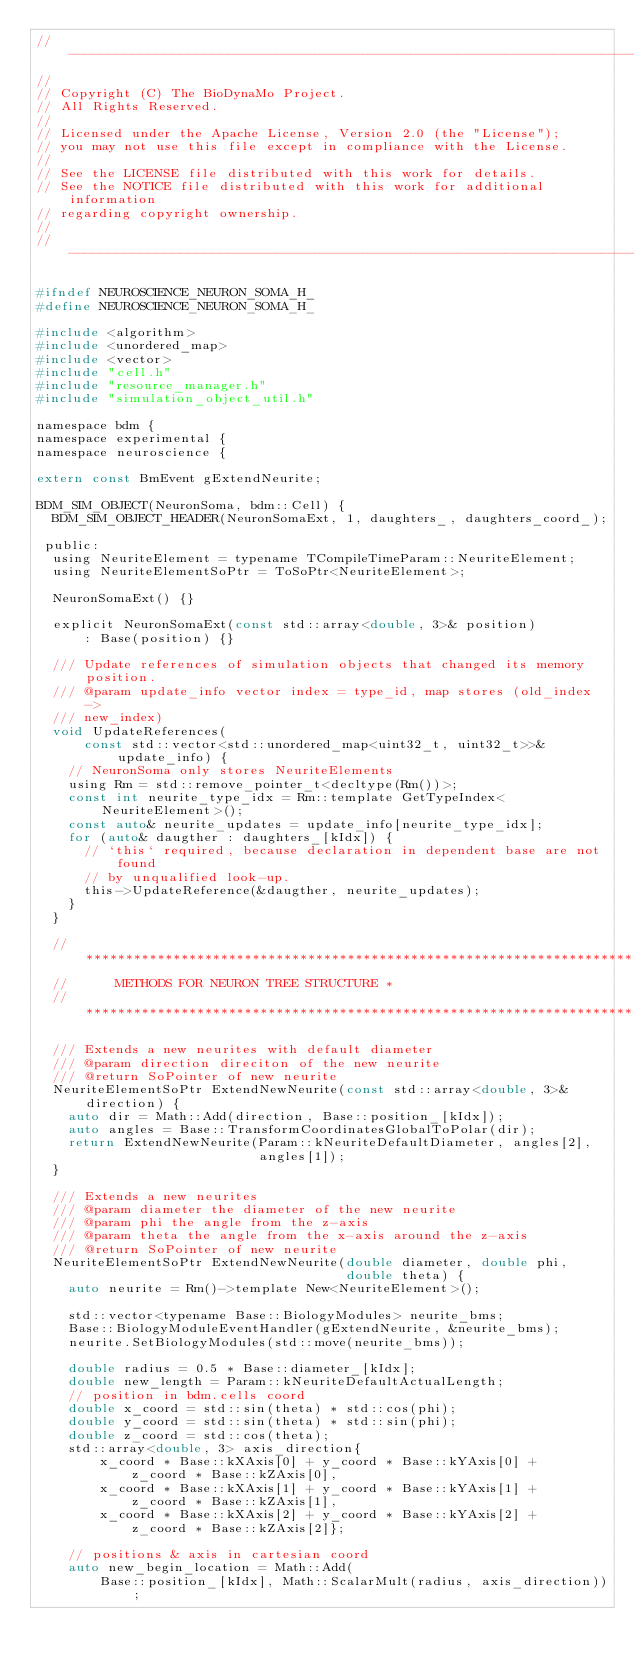<code> <loc_0><loc_0><loc_500><loc_500><_C_>// -----------------------------------------------------------------------------
//
// Copyright (C) The BioDynaMo Project.
// All Rights Reserved.
//
// Licensed under the Apache License, Version 2.0 (the "License");
// you may not use this file except in compliance with the License.
//
// See the LICENSE file distributed with this work for details.
// See the NOTICE file distributed with this work for additional information
// regarding copyright ownership.
//
// -----------------------------------------------------------------------------

#ifndef NEUROSCIENCE_NEURON_SOMA_H_
#define NEUROSCIENCE_NEURON_SOMA_H_

#include <algorithm>
#include <unordered_map>
#include <vector>
#include "cell.h"
#include "resource_manager.h"
#include "simulation_object_util.h"

namespace bdm {
namespace experimental {
namespace neuroscience {

extern const BmEvent gExtendNeurite;

BDM_SIM_OBJECT(NeuronSoma, bdm::Cell) {
  BDM_SIM_OBJECT_HEADER(NeuronSomaExt, 1, daughters_, daughters_coord_);

 public:
  using NeuriteElement = typename TCompileTimeParam::NeuriteElement;
  using NeuriteElementSoPtr = ToSoPtr<NeuriteElement>;

  NeuronSomaExt() {}

  explicit NeuronSomaExt(const std::array<double, 3>& position)
      : Base(position) {}

  /// Update references of simulation objects that changed its memory position.
  /// @param update_info vector index = type_id, map stores (old_index ->
  /// new_index)
  void UpdateReferences(
      const std::vector<std::unordered_map<uint32_t, uint32_t>>& update_info) {
    // NeuronSoma only stores NeuriteElements
    using Rm = std::remove_pointer_t<decltype(Rm())>;
    const int neurite_type_idx = Rm::template GetTypeIndex<NeuriteElement>();
    const auto& neurite_updates = update_info[neurite_type_idx];
    for (auto& daugther : daughters_[kIdx]) {
      // `this` required, because declaration in dependent base are not found
      // by unqualified look-up.
      this->UpdateReference(&daugther, neurite_updates);
    }
  }

  // ***************************************************************************
  //      METHODS FOR NEURON TREE STRUCTURE *
  // ***************************************************************************

  /// Extends a new neurites with default diameter
  /// @param direction direciton of the new neurite
  /// @return SoPointer of new neurite
  NeuriteElementSoPtr ExtendNewNeurite(const std::array<double, 3>& direction) {
    auto dir = Math::Add(direction, Base::position_[kIdx]);
    auto angles = Base::TransformCoordinatesGlobalToPolar(dir);
    return ExtendNewNeurite(Param::kNeuriteDefaultDiameter, angles[2],
                            angles[1]);
  }

  /// Extends a new neurites
  /// @param diameter the diameter of the new neurite
  /// @param phi the angle from the z-axis
  /// @param theta the angle from the x-axis around the z-axis
  /// @return SoPointer of new neurite
  NeuriteElementSoPtr ExtendNewNeurite(double diameter, double phi,
                                       double theta) {
    auto neurite = Rm()->template New<NeuriteElement>();

    std::vector<typename Base::BiologyModules> neurite_bms;
    Base::BiologyModuleEventHandler(gExtendNeurite, &neurite_bms);
    neurite.SetBiologyModules(std::move(neurite_bms));

    double radius = 0.5 * Base::diameter_[kIdx];
    double new_length = Param::kNeuriteDefaultActualLength;
    // position in bdm.cells coord
    double x_coord = std::sin(theta) * std::cos(phi);
    double y_coord = std::sin(theta) * std::sin(phi);
    double z_coord = std::cos(theta);
    std::array<double, 3> axis_direction{
        x_coord * Base::kXAxis[0] + y_coord * Base::kYAxis[0] +
            z_coord * Base::kZAxis[0],
        x_coord * Base::kXAxis[1] + y_coord * Base::kYAxis[1] +
            z_coord * Base::kZAxis[1],
        x_coord * Base::kXAxis[2] + y_coord * Base::kYAxis[2] +
            z_coord * Base::kZAxis[2]};

    // positions & axis in cartesian coord
    auto new_begin_location = Math::Add(
        Base::position_[kIdx], Math::ScalarMult(radius, axis_direction));</code> 